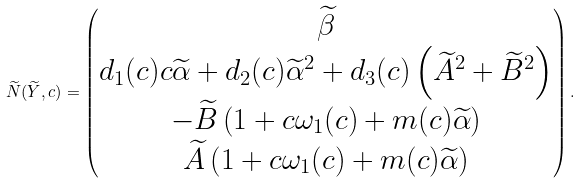<formula> <loc_0><loc_0><loc_500><loc_500>\widetilde { N } ( \widetilde { Y } , c ) = \begin{pmatrix} \widetilde { \beta } \\ d _ { 1 } ( c ) c \widetilde { \alpha } + d _ { 2 } ( c ) \widetilde { \alpha } ^ { 2 } + d _ { 3 } ( c ) \left ( \widetilde { A } ^ { 2 } + \widetilde { B } ^ { 2 } \right ) \\ - \widetilde { B } \left ( 1 + c \omega _ { 1 } ( c ) + m ( c ) \widetilde { \alpha } \right ) \\ \widetilde { A } \left ( 1 + c \omega _ { 1 } ( c ) + m ( c ) \widetilde { \alpha } \right ) \end{pmatrix} .</formula> 